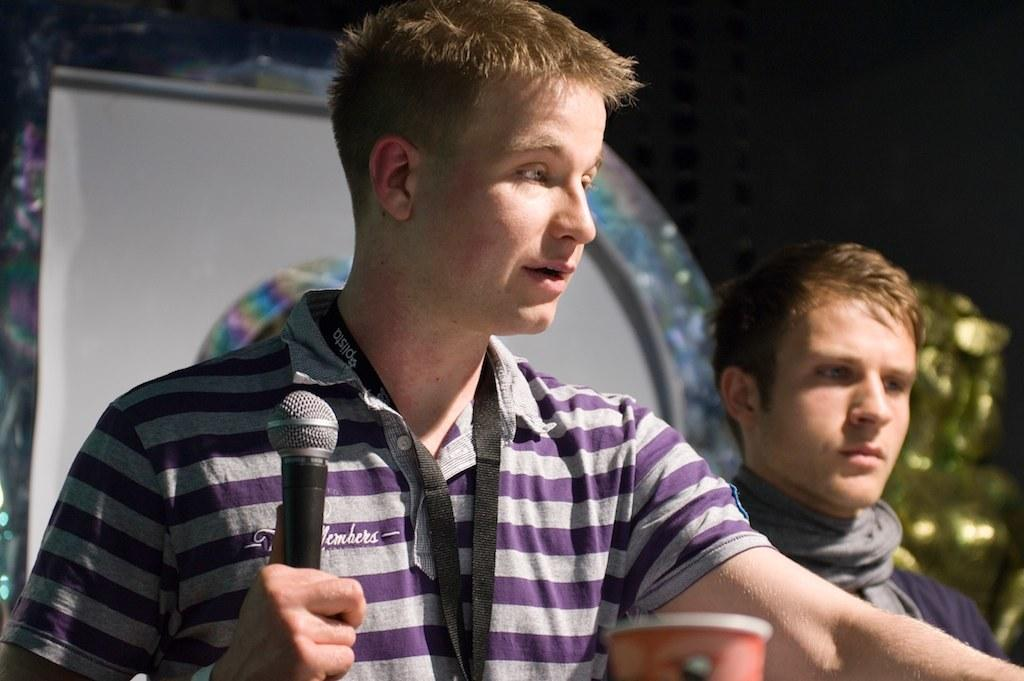What is the man in the image holding? The man is holding a mic in the image. How is the man holding the mic? The man is holding the mic with his hand. Can you describe the other man in the image? The second man is wearing a scarf. What is present between the two men? There is a glass in front of the two men. What can be seen in the background of the image? There is a wall and some light visible in the background. What type of nerve is visible in the image? There is no nerve visible in the image; it features two men, one holding a mic, and a glass between them. 